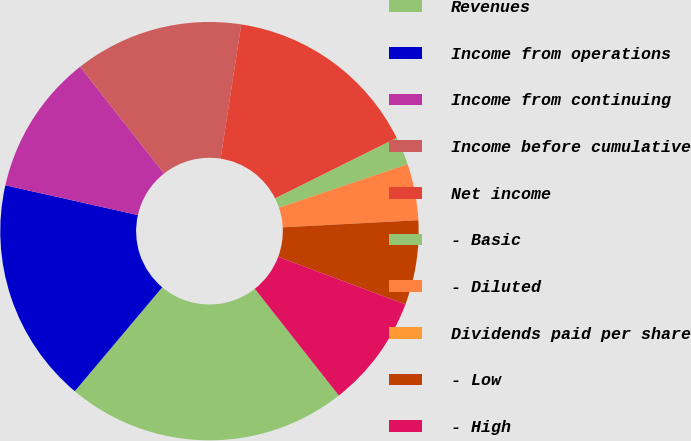<chart> <loc_0><loc_0><loc_500><loc_500><pie_chart><fcel>Revenues<fcel>Income from operations<fcel>Income from continuing<fcel>Income before cumulative<fcel>Net income<fcel>- Basic<fcel>- Diluted<fcel>Dividends paid per share<fcel>- Low<fcel>- High<nl><fcel>21.74%<fcel>17.39%<fcel>10.87%<fcel>13.04%<fcel>15.22%<fcel>2.17%<fcel>4.35%<fcel>0.0%<fcel>6.52%<fcel>8.7%<nl></chart> 